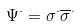<formula> <loc_0><loc_0><loc_500><loc_500>\Psi ^ { \cdot } = \sigma ^ { \cdot } \overline { \sigma } ^ { \cdot }</formula> 